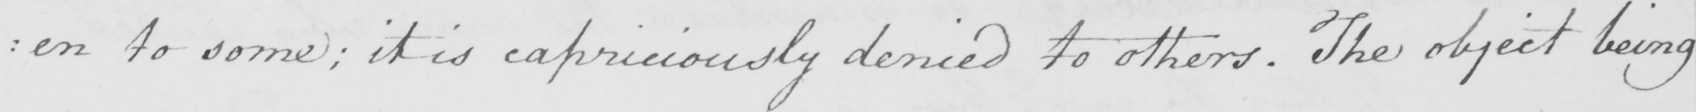Please provide the text content of this handwritten line. : en to some ; it is capriciously denied to others . The object being 